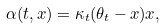Convert formula to latex. <formula><loc_0><loc_0><loc_500><loc_500>\alpha ( t , x ) = \kappa _ { t } ( \theta _ { t } - x ) x ,</formula> 